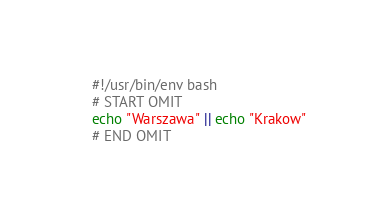<code> <loc_0><loc_0><loc_500><loc_500><_Bash_>#!/usr/bin/env bash
# START OMIT
echo "Warszawa" || echo "Krakow"
# END OMIT</code> 